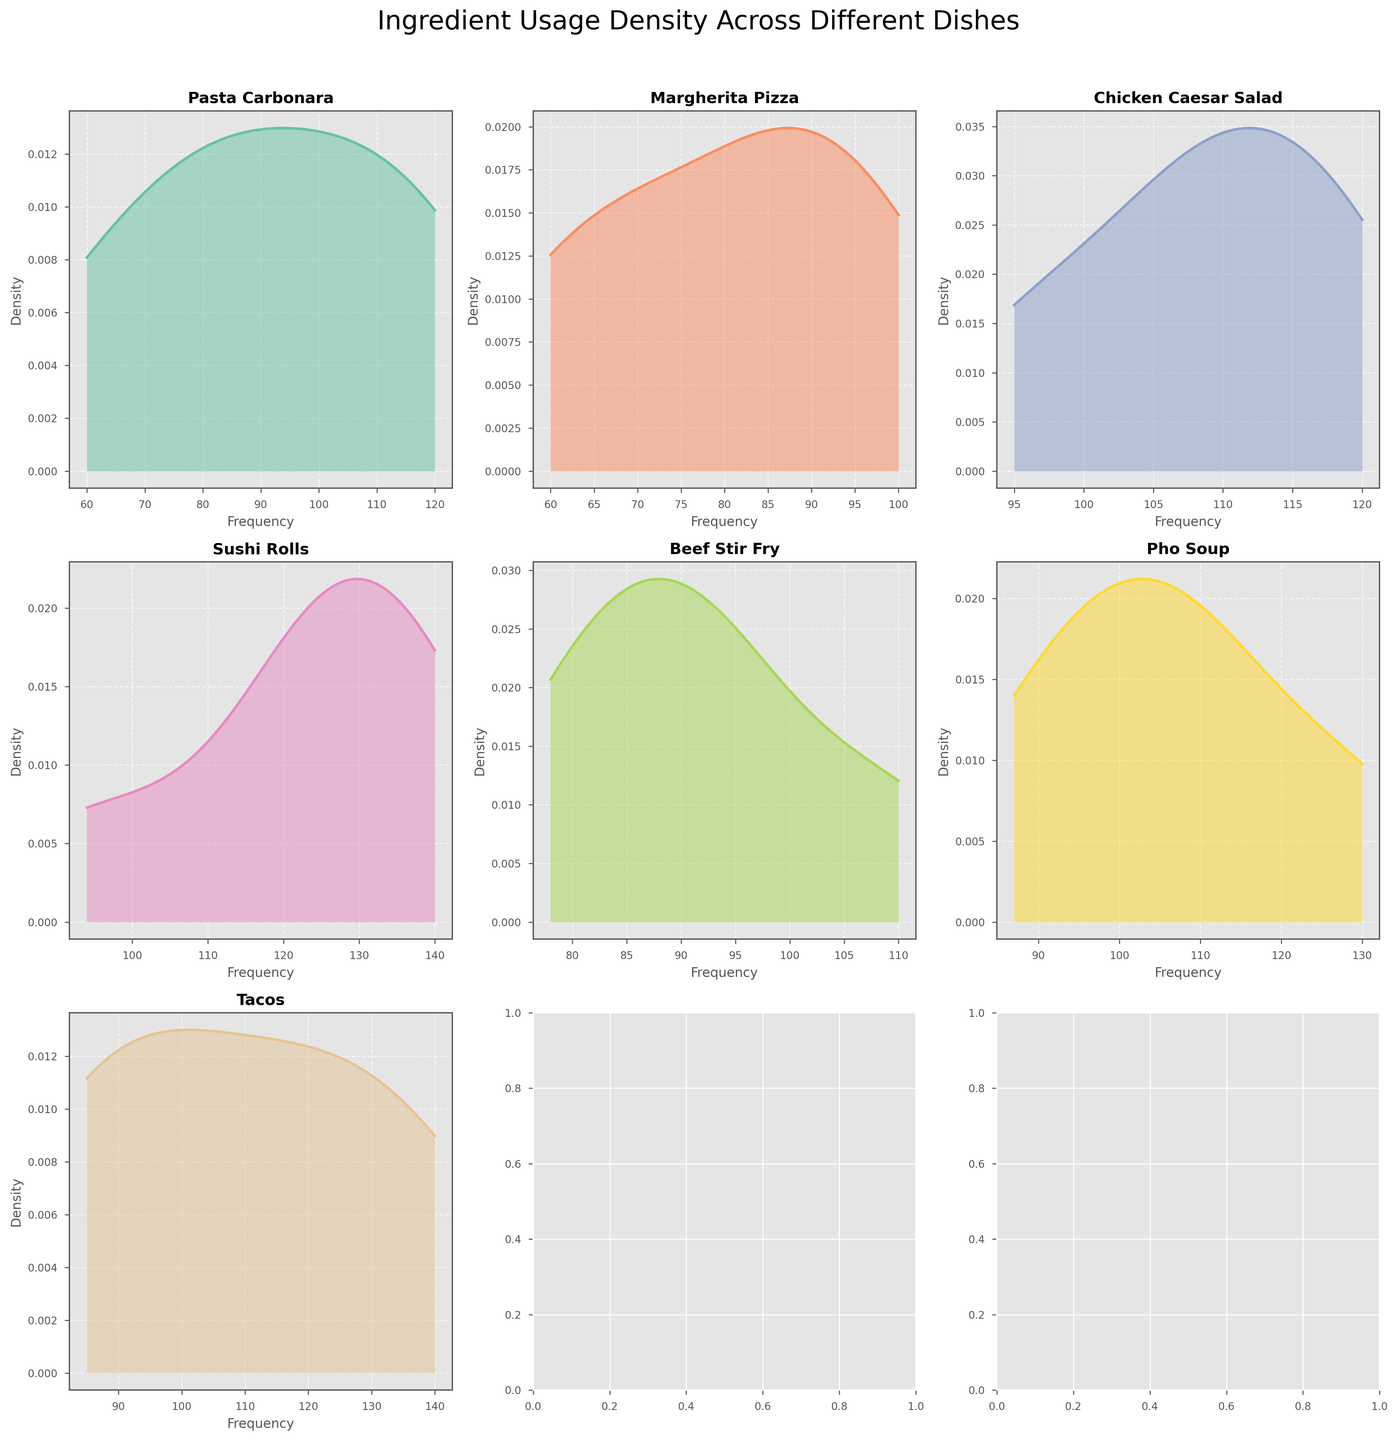Which dish has the highest density peak? To determine the dish with the highest density peak, look for the plot that has the maximum y-axis value among all subplots. In this case, Sushi Rolls has the highest peak in density.
Answer: Sushi Rolls Which dish uses ingredients with frequencies ranging up to 140? Check the x-axis ranges of each subplot to see which plot extends up to 140. Tacos and Sushi Rolls both have ingredients that reach a frequency of 140.
Answer: Tacos, Sushi Rolls What is the most frequently used ingredient in Sushi Rolls based on the density plot? Look at the density plot for Sushi Rolls and observe where the peak occurs on the x-axis. The highest peak occurs around 140, which corresponds to Sushi Rice.
Answer: Sushi Rice Which dish has the most evenly distributed ingredient usage frequencies? Check the subplots where the density curve is flatter and more spread out across the x-axis. Pasta Carbonara has a relatively more even distribution compared to the others.
Answer: Pasta Carbonara Between Margherita Pizza and Chicken Caesar Salad, which dish has a higher variability in ingredient usage frequency? Variability can be judged by the spread of the density curve along the x-axis. Chicken Caesar Salad shows a wider spread in its density curve, indicating higher variability.
Answer: Chicken Caesar Salad Does Beef Stir Fry or Pho Soup have a broader range of ingredient usage frequencies? Compare the x-axis ranges of the Beef Stir Fry and Pho Soup subplots. Pho Soup has frequencies that range up to higher values compared to Beef Stir Fry.
Answer: Pho Soup Which dish has a density plot closest to a normal distribution? Find the density plot that looks most like a bell curve. The density plot for Pasta Carbonara appears closest to a normal distribution.
Answer: Pasta Carbonara What is the range of ingredient usage frequencies for Tacos? Look at the x-axis range for the Tacos subplot. The frequencies range from around 85 to 140.
Answer: 85 to 140 How does the density peak of Chicken Caesar Salad compare with that of Margherita Pizza? Compare the height of the peaks in the density plots for Chicken Caesar Salad and Margherita Pizza. Chicken Caesar Salad has a higher peak compared to Margherita Pizza.
Answer: Chicken Caesar Salad Which dish has ingredients with the closest frequency usage? Look for the subplot where the density curve is the narrowest. Sushi Rolls' density plot indicates that its ingredients have the closest frequency usage.
Answer: Sushi Rolls 